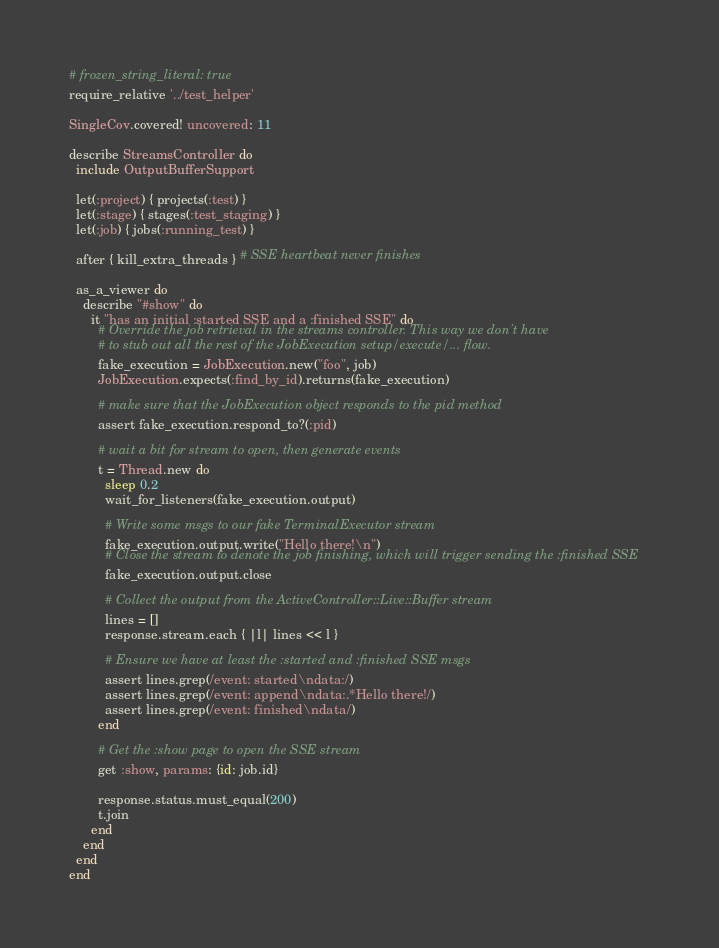<code> <loc_0><loc_0><loc_500><loc_500><_Ruby_># frozen_string_literal: true
require_relative '../test_helper'

SingleCov.covered! uncovered: 11

describe StreamsController do
  include OutputBufferSupport

  let(:project) { projects(:test) }
  let(:stage) { stages(:test_staging) }
  let(:job) { jobs(:running_test) }

  after { kill_extra_threads } # SSE heartbeat never finishes

  as_a_viewer do
    describe "#show" do
      it "has an initial :started SSE and a :finished SSE" do
        # Override the job retrieval in the streams controller. This way we don't have
        # to stub out all the rest of the JobExecution setup/execute/... flow.
        fake_execution = JobExecution.new("foo", job)
        JobExecution.expects(:find_by_id).returns(fake_execution)

        # make sure that the JobExecution object responds to the pid method
        assert fake_execution.respond_to?(:pid)

        # wait a bit for stream to open, then generate events
        t = Thread.new do
          sleep 0.2
          wait_for_listeners(fake_execution.output)

          # Write some msgs to our fake TerminalExecutor stream
          fake_execution.output.write("Hello there!\n")
          # Close the stream to denote the job finishing, which will trigger sending the :finished SSE
          fake_execution.output.close

          # Collect the output from the ActiveController::Live::Buffer stream
          lines = []
          response.stream.each { |l| lines << l }

          # Ensure we have at least the :started and :finished SSE msgs
          assert lines.grep(/event: started\ndata:/)
          assert lines.grep(/event: append\ndata:.*Hello there!/)
          assert lines.grep(/event: finished\ndata/)
        end

        # Get the :show page to open the SSE stream
        get :show, params: {id: job.id}

        response.status.must_equal(200)
        t.join
      end
    end
  end
end
</code> 